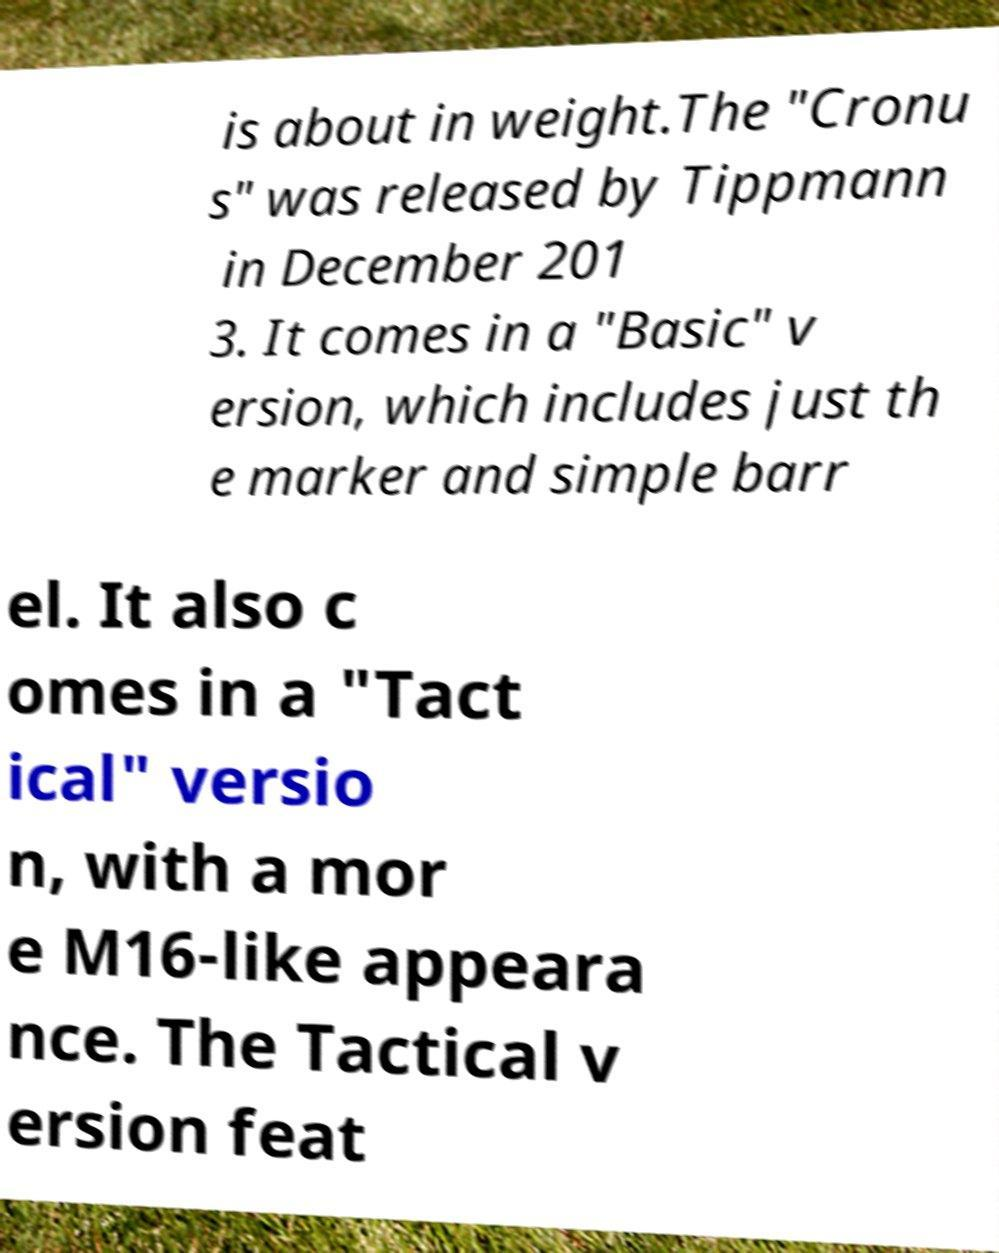Please identify and transcribe the text found in this image. is about in weight.The "Cronu s" was released by Tippmann in December 201 3. It comes in a "Basic" v ersion, which includes just th e marker and simple barr el. It also c omes in a "Tact ical" versio n, with a mor e M16-like appeara nce. The Tactical v ersion feat 